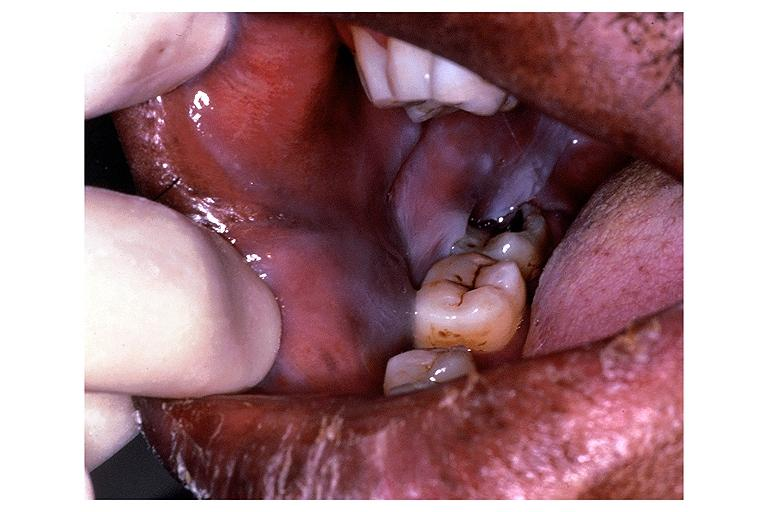what does this image show?
Answer the question using a single word or phrase. Leukoedema 